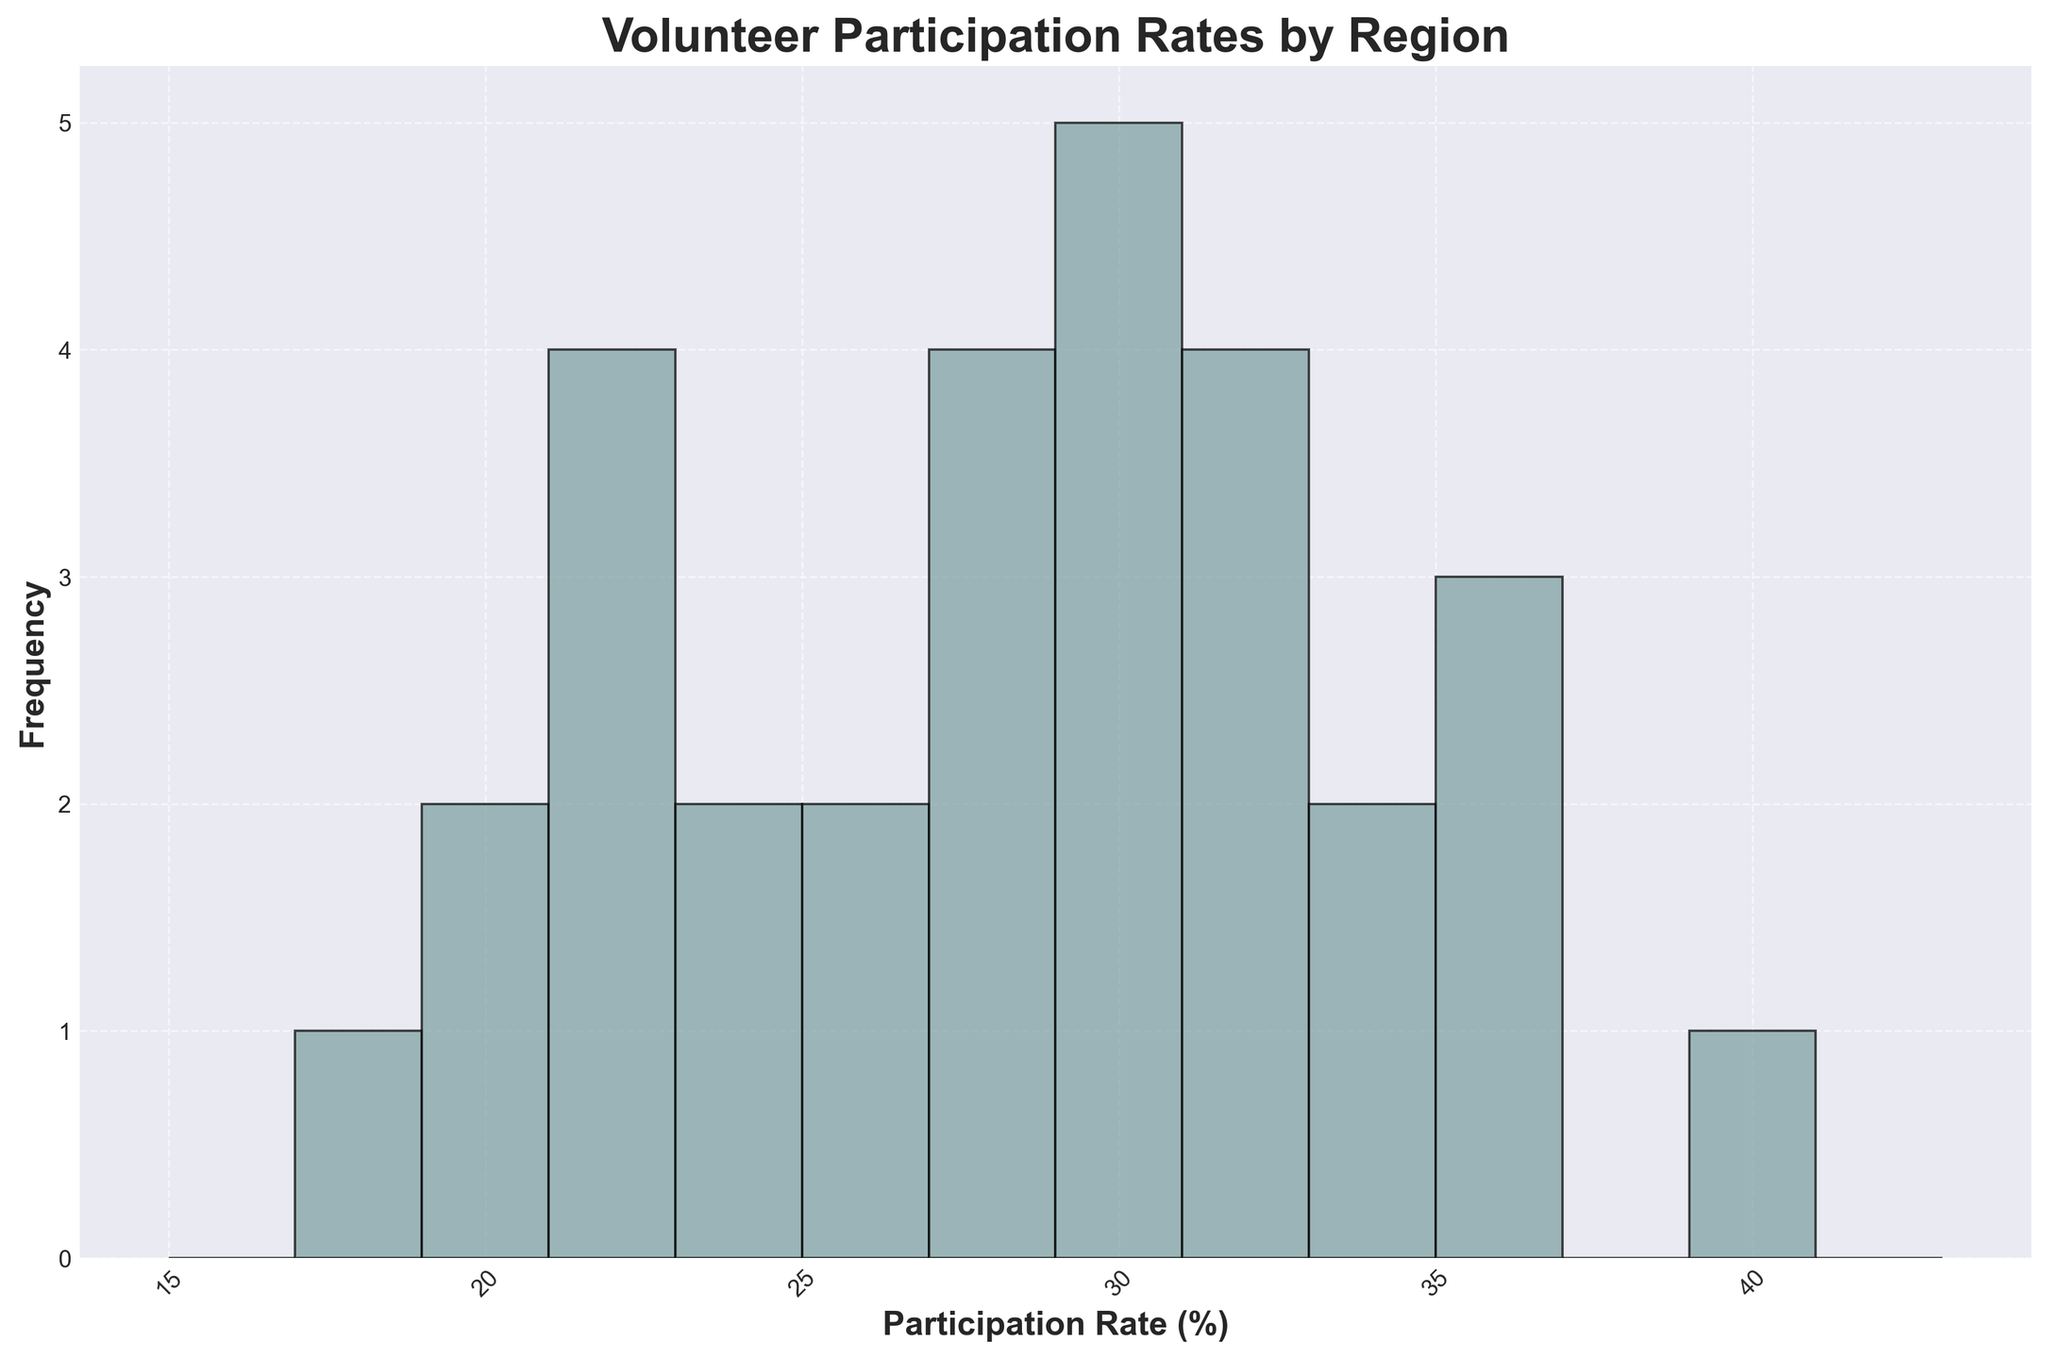What's the most common range for volunteer participation rates across all regions? By observing the histogram bars, we can identify the range where the tallest bar is found. This range represents the most common volunteer participation rates.
Answer: 28-30% Which geographic region has the highest volunteer participation rate? By checking the data, we identify that North America's highest rate is 40%, which is the highest among all regions.
Answer: North America How many regions have their highest volunteer participation rate above 30%? By comparing the highest participation rates in each region: North America (40%), Europe (30%), Asia (25%), South America (35%), Africa (22%), Australia (31%).
Answer: 3 What is the approximate average volunteer participation rate for Asia? Summing the rates for Asia (24, 22, 23, 25, 21) and dividing by the number of entries: (24 + 22 + 23 + 25 + 21) / 5 = 23
Answer: 23 What's the range of volunteer participation rates observed in Africa? The participation rates for Africa are (20, 22, 18, 19, 21). The range is calculated by subtracting the minimum value from the maximum value (22 - 18).
Answer: 4 Which regions have a benefit in increasing their volunteer participation rate based on the histogram visualization? By comparing regions with lower frequencies or lower participation rates like Asia and Africa, they can be targeted for improvement.
Answer: Asia, Africa 